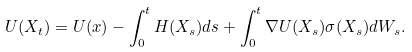<formula> <loc_0><loc_0><loc_500><loc_500>U ( X _ { t } ) = U ( x ) - \int _ { 0 } ^ { t } H ( X _ { s } ) d s + \int _ { 0 } ^ { t } \nabla U ( X _ { s } ) \sigma ( X _ { s } ) d W _ { s } .</formula> 